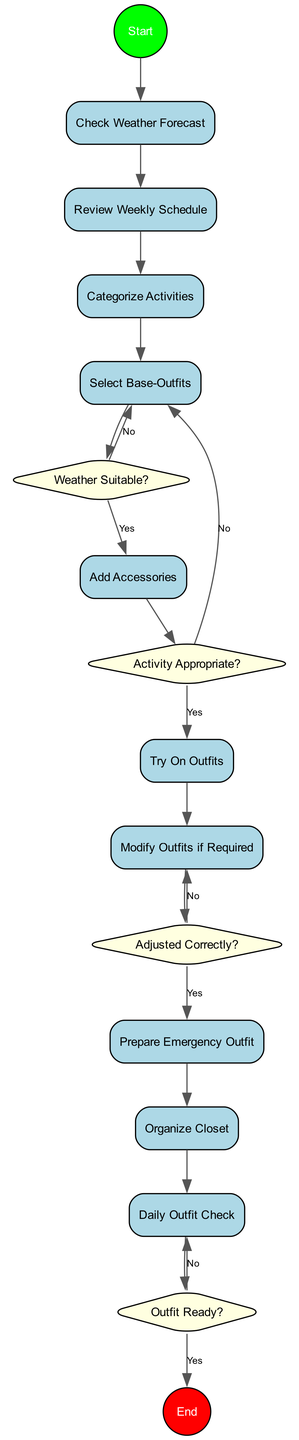What is the first activity in the diagram? The diagram starts with the "Check Weather Forecast" activity, as indicated by the edge from the start node to this first activity.
Answer: Check Weather Forecast How many decisions are there in the diagram? The diagram contains four decision nodes, as counted by identifying the diamond-shaped nodes in the flow.
Answer: 4 What is the last activity before the end node? The last activity before reaching the end node is the "Daily Outfit Check," as shown by the edge connecting this activity to the decision node labeled "Outfit Ready?"
Answer: Daily Outfit Check Which activity comes after "Select Base-Outfits"? The activity that follows "Select Base-Outfits" is the decision "Weather Suitable?". This follows directly after selecting base outfits according to the flow.
Answer: Weather Suitable? What happens if the selected outfits are not suitable for the expected weather? If the selected outfits are not suitable for the expected weather (as indicated by the "No" edge), the flow returns to the "Select Base-Outfits" activity, allowing for a reevaluation of the chosen outfits.
Answer: Select Base-Outfits Which activity is categorized as a 'formal' activity? The diagram does not specify a particular activity as 'formal', but categorization occurs during the "Categorize Activities" step, which groups activities based on their nature.
Answer: Categorize Activities How do adjustments get made after the try-on session? After the "Try On Outfits" activity, if the adjustments are deemed necessary, the flow proceeds to the "Modify Outfits if Required," which implies making the necessary changes.
Answer: Modify Outfits if Required What is the outcome if the necessary adjustments were not made correctly? If the adjustments were not made correctly (indicated by the "No" edge from "Adjusted Correctly?"), the flow loops back to "Try On Outfits" for another fitting session.
Answer: Try On Outfits 